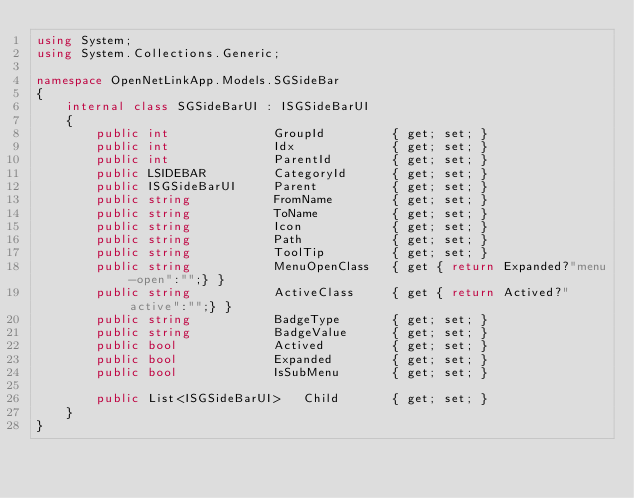<code> <loc_0><loc_0><loc_500><loc_500><_C#_>using System;
using System.Collections.Generic;

namespace OpenNetLinkApp.Models.SGSideBar
{
    internal class SGSideBarUI : ISGSideBarUI
    {
        public int              GroupId         { get; set; }
        public int              Idx             { get; set; }
        public int              ParentId        { get; set; }
        public LSIDEBAR         CategoryId      { get; set; }
        public ISGSideBarUI 	Parent          { get; set; }
        public string 		    FromName        { get; set; }
        public string 		    ToName          { get; set; }
        public string 		    Icon            { get; set; }
        public string 	    	Path            { get; set; }
        public string 		    ToolTip         { get; set; }
        public string 		    MenuOpenClass   { get { return Expanded?"menu-open":"";} }
        public string 		    ActiveClass     { get { return Actived?"active":"";} }
        public string     		BadgeType       { get; set; }
        public string     		BadgeValue      { get; set; }
        public bool 		    Actived         { get; set; }
        public bool 		    Expanded        { get; set; }
        public bool 		    IsSubMenu       { get; set; }
        
        public List<ISGSideBarUI>   Child       { get; set; }     
    }
}</code> 